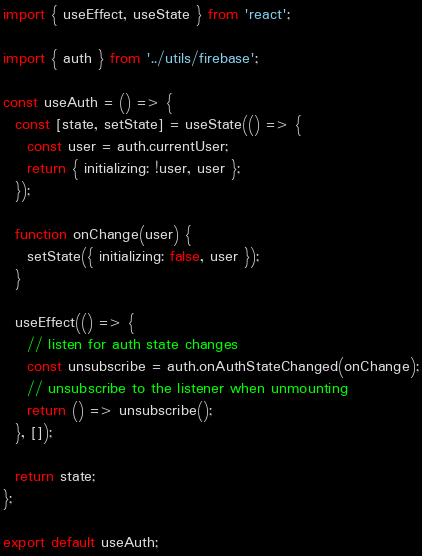<code> <loc_0><loc_0><loc_500><loc_500><_JavaScript_>import { useEffect, useState } from 'react';

import { auth } from '../utils/firebase';

const useAuth = () => {
  const [state, setState] = useState(() => {
    const user = auth.currentUser;
    return { initializing: !user, user };
  });

  function onChange(user) {
    setState({ initializing: false, user });
  }

  useEffect(() => {
    // listen for auth state changes
    const unsubscribe = auth.onAuthStateChanged(onChange);
    // unsubscribe to the listener when unmounting
    return () => unsubscribe();
  }, []);

  return state;
};

export default useAuth;
</code> 